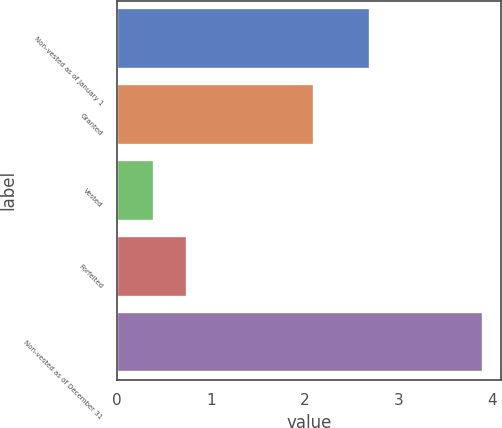Convert chart. <chart><loc_0><loc_0><loc_500><loc_500><bar_chart><fcel>Non-vested as of January 1<fcel>Granted<fcel>Vested<fcel>Forfeited<fcel>Non-vested as of December 31<nl><fcel>2.7<fcel>2.1<fcel>0.4<fcel>0.75<fcel>3.9<nl></chart> 